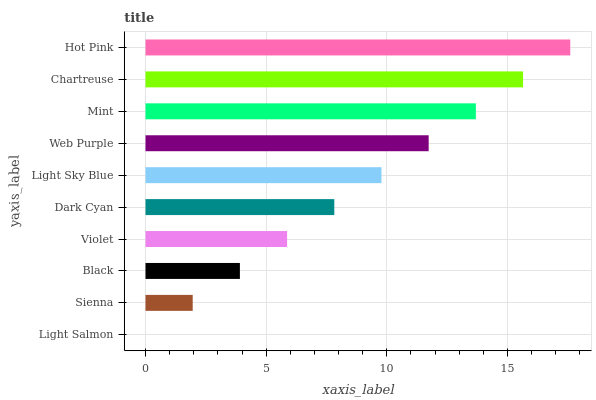Is Light Salmon the minimum?
Answer yes or no. Yes. Is Hot Pink the maximum?
Answer yes or no. Yes. Is Sienna the minimum?
Answer yes or no. No. Is Sienna the maximum?
Answer yes or no. No. Is Sienna greater than Light Salmon?
Answer yes or no. Yes. Is Light Salmon less than Sienna?
Answer yes or no. Yes. Is Light Salmon greater than Sienna?
Answer yes or no. No. Is Sienna less than Light Salmon?
Answer yes or no. No. Is Light Sky Blue the high median?
Answer yes or no. Yes. Is Dark Cyan the low median?
Answer yes or no. Yes. Is Web Purple the high median?
Answer yes or no. No. Is Black the low median?
Answer yes or no. No. 